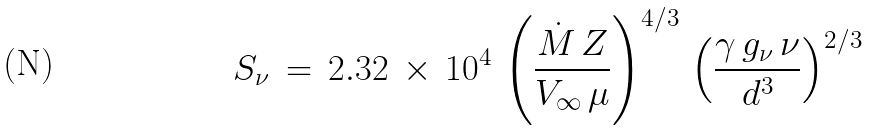<formula> <loc_0><loc_0><loc_500><loc_500>S _ { \nu } \, = \, 2 . 3 2 \, \times \, 1 0 ^ { 4 } \, \left ( \frac { \dot { M } \, Z } { V _ { \infty } \, \mu } \right ) ^ { 4 / 3 } \, \left ( \frac { \gamma \, g _ { \nu } \, \nu } { d ^ { 3 } } \right ) ^ { 2 / 3 }</formula> 